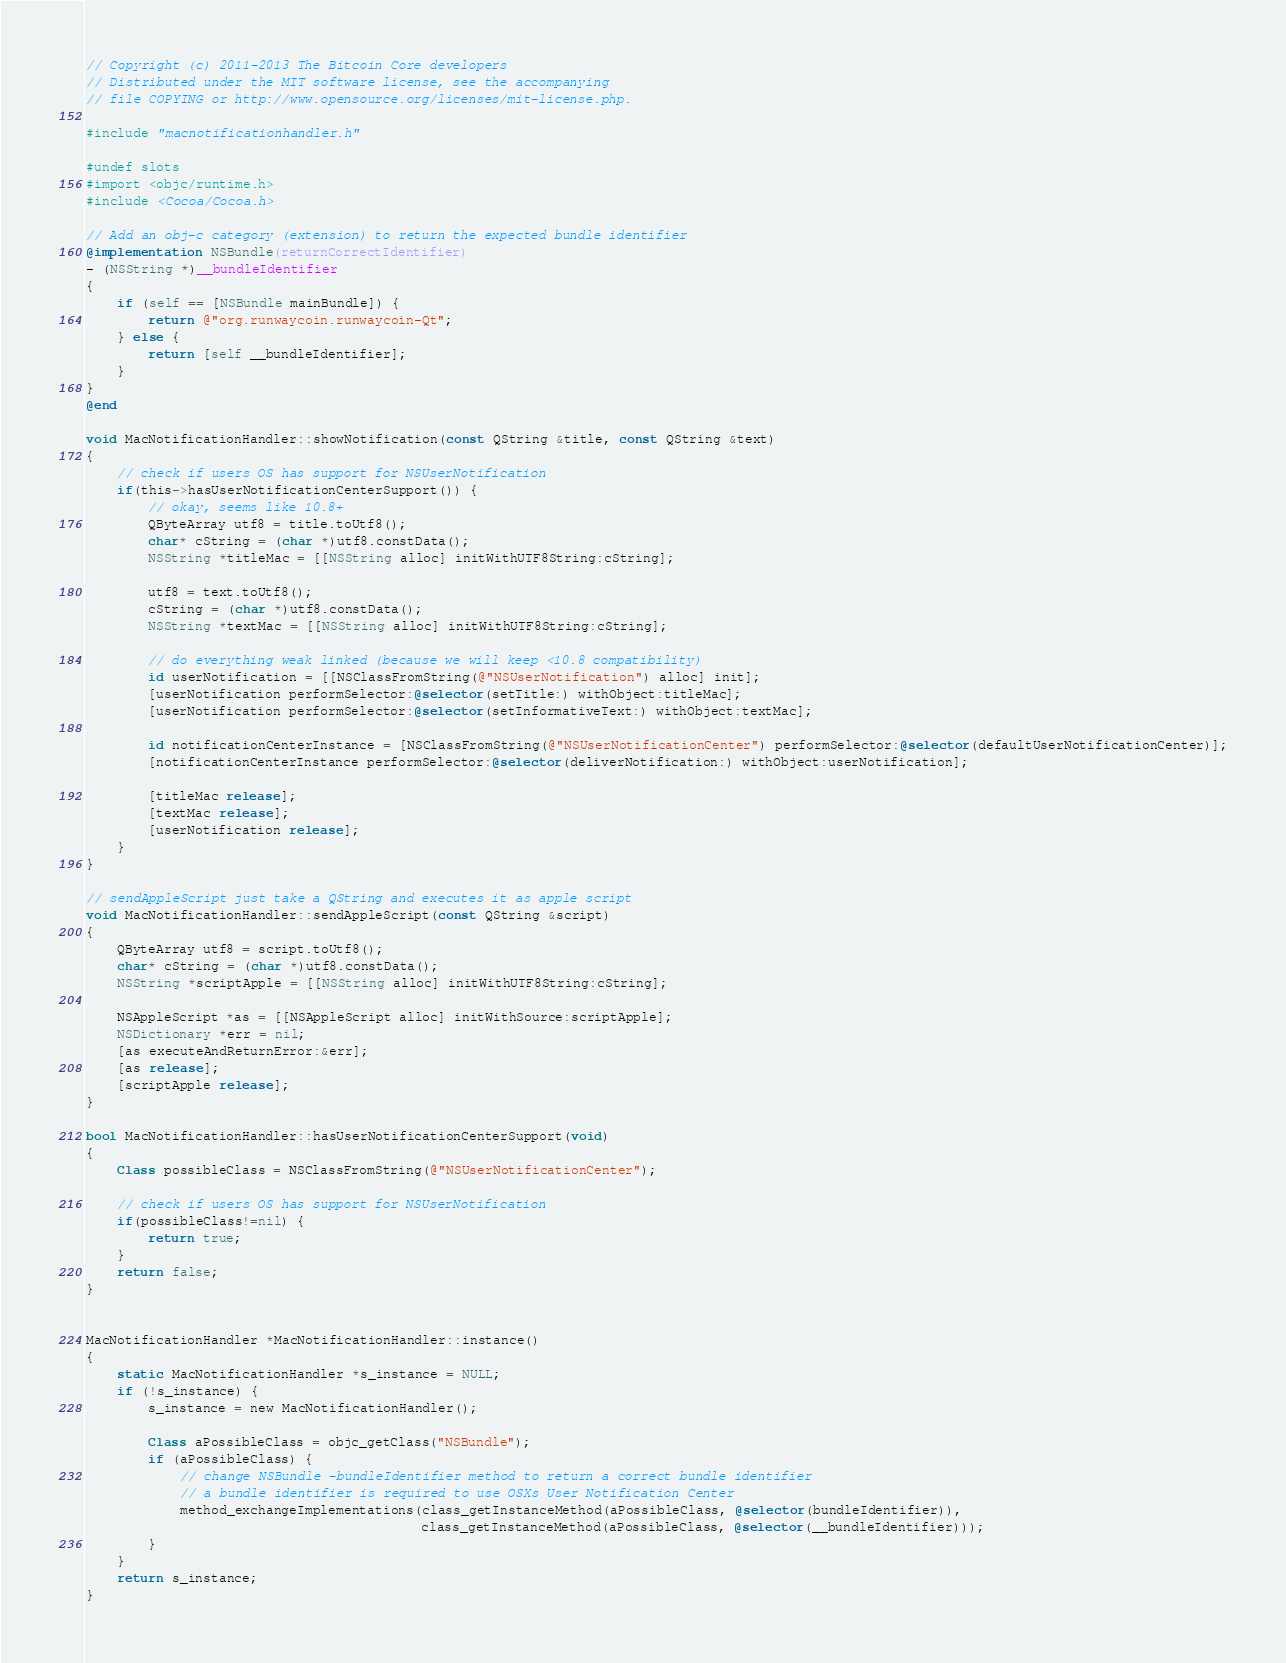Convert code to text. <code><loc_0><loc_0><loc_500><loc_500><_ObjectiveC_>// Copyright (c) 2011-2013 The Bitcoin Core developers
// Distributed under the MIT software license, see the accompanying
// file COPYING or http://www.opensource.org/licenses/mit-license.php.

#include "macnotificationhandler.h"

#undef slots
#import <objc/runtime.h>
#include <Cocoa/Cocoa.h>

// Add an obj-c category (extension) to return the expected bundle identifier
@implementation NSBundle(returnCorrectIdentifier)
- (NSString *)__bundleIdentifier
{
    if (self == [NSBundle mainBundle]) {
        return @"org.runwaycoin.runwaycoin-Qt";
    } else {
        return [self __bundleIdentifier];
    }
}
@end

void MacNotificationHandler::showNotification(const QString &title, const QString &text)
{
    // check if users OS has support for NSUserNotification
    if(this->hasUserNotificationCenterSupport()) {
        // okay, seems like 10.8+
        QByteArray utf8 = title.toUtf8();
        char* cString = (char *)utf8.constData();
        NSString *titleMac = [[NSString alloc] initWithUTF8String:cString];

        utf8 = text.toUtf8();
        cString = (char *)utf8.constData();
        NSString *textMac = [[NSString alloc] initWithUTF8String:cString];

        // do everything weak linked (because we will keep <10.8 compatibility)
        id userNotification = [[NSClassFromString(@"NSUserNotification") alloc] init];
        [userNotification performSelector:@selector(setTitle:) withObject:titleMac];
        [userNotification performSelector:@selector(setInformativeText:) withObject:textMac];

        id notificationCenterInstance = [NSClassFromString(@"NSUserNotificationCenter") performSelector:@selector(defaultUserNotificationCenter)];
        [notificationCenterInstance performSelector:@selector(deliverNotification:) withObject:userNotification];

        [titleMac release];
        [textMac release];
        [userNotification release];
    }
}

// sendAppleScript just take a QString and executes it as apple script
void MacNotificationHandler::sendAppleScript(const QString &script)
{
    QByteArray utf8 = script.toUtf8();
    char* cString = (char *)utf8.constData();
    NSString *scriptApple = [[NSString alloc] initWithUTF8String:cString];

    NSAppleScript *as = [[NSAppleScript alloc] initWithSource:scriptApple];
    NSDictionary *err = nil;
    [as executeAndReturnError:&err];
    [as release];
    [scriptApple release];
}

bool MacNotificationHandler::hasUserNotificationCenterSupport(void)
{
    Class possibleClass = NSClassFromString(@"NSUserNotificationCenter");

    // check if users OS has support for NSUserNotification
    if(possibleClass!=nil) {
        return true;
    }
    return false;
}


MacNotificationHandler *MacNotificationHandler::instance()
{
    static MacNotificationHandler *s_instance = NULL;
    if (!s_instance) {
        s_instance = new MacNotificationHandler();
        
        Class aPossibleClass = objc_getClass("NSBundle");
        if (aPossibleClass) {
            // change NSBundle -bundleIdentifier method to return a correct bundle identifier
            // a bundle identifier is required to use OSXs User Notification Center
            method_exchangeImplementations(class_getInstanceMethod(aPossibleClass, @selector(bundleIdentifier)),
                                           class_getInstanceMethod(aPossibleClass, @selector(__bundleIdentifier)));
        }
    }
    return s_instance;
}
</code> 